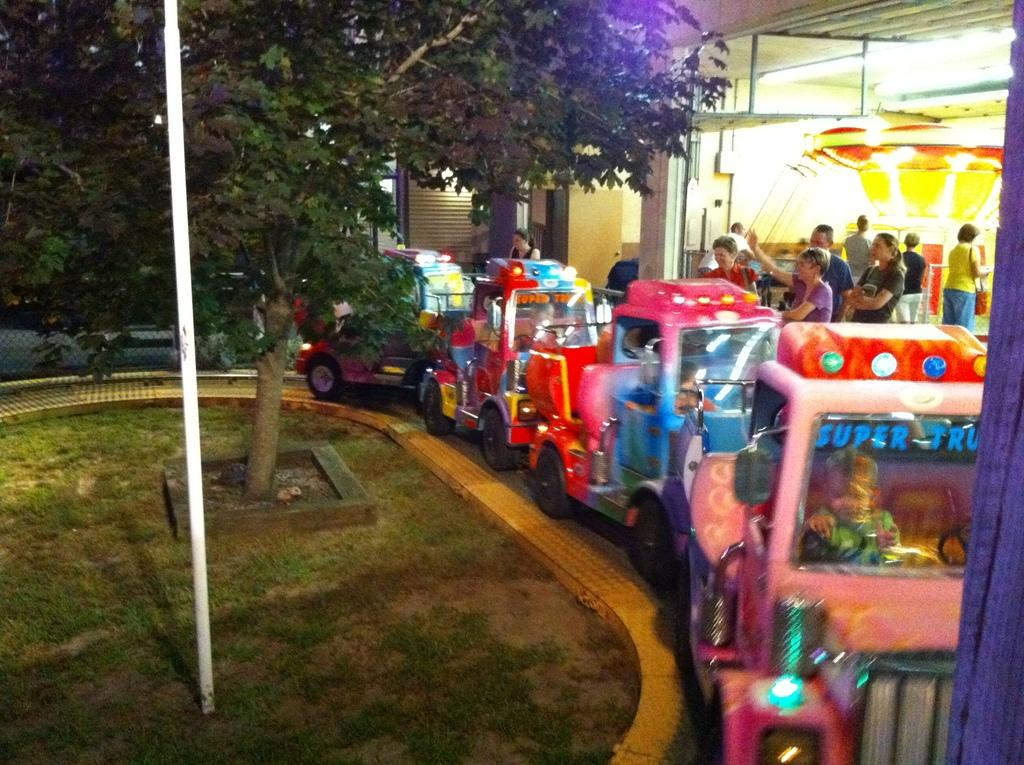What is happening on the road in the image? There are cars on a road in the image. What can be seen on the left side of the image? There is a tree and a pole on the left side of the image. What is visible in the background of the image? There are people standing and a shopping mall in the background of the image. What type of battle is taking place in the image? There is no battle present in the image; it features cars on a road, a tree and a pole on the left side, and people and a shopping mall in the background. How many beds are visible in the image? There are no beds present in the image. 